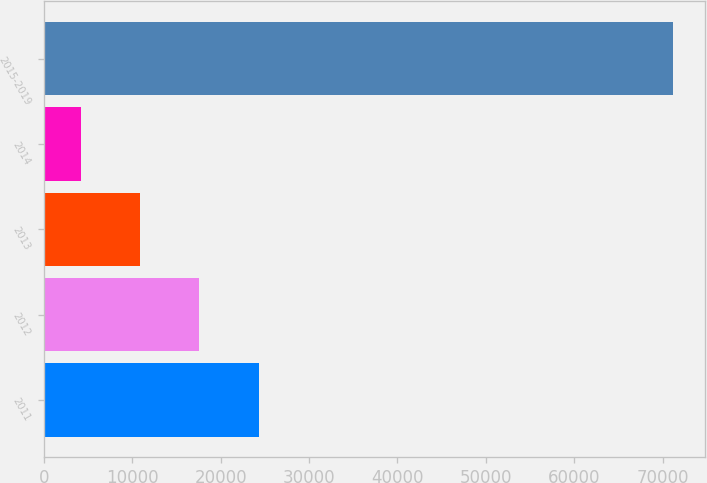<chart> <loc_0><loc_0><loc_500><loc_500><bar_chart><fcel>2011<fcel>2012<fcel>2013<fcel>2014<fcel>2015-2019<nl><fcel>24296.1<fcel>17596.4<fcel>10896.7<fcel>4197<fcel>71194<nl></chart> 